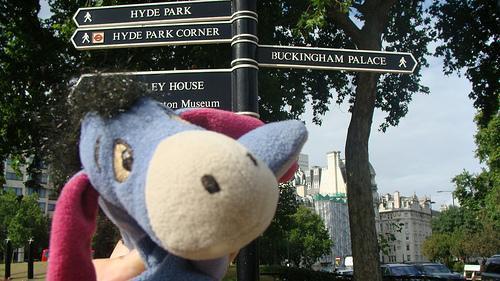How many street signs are to the right of the pole?
Give a very brief answer. 1. 